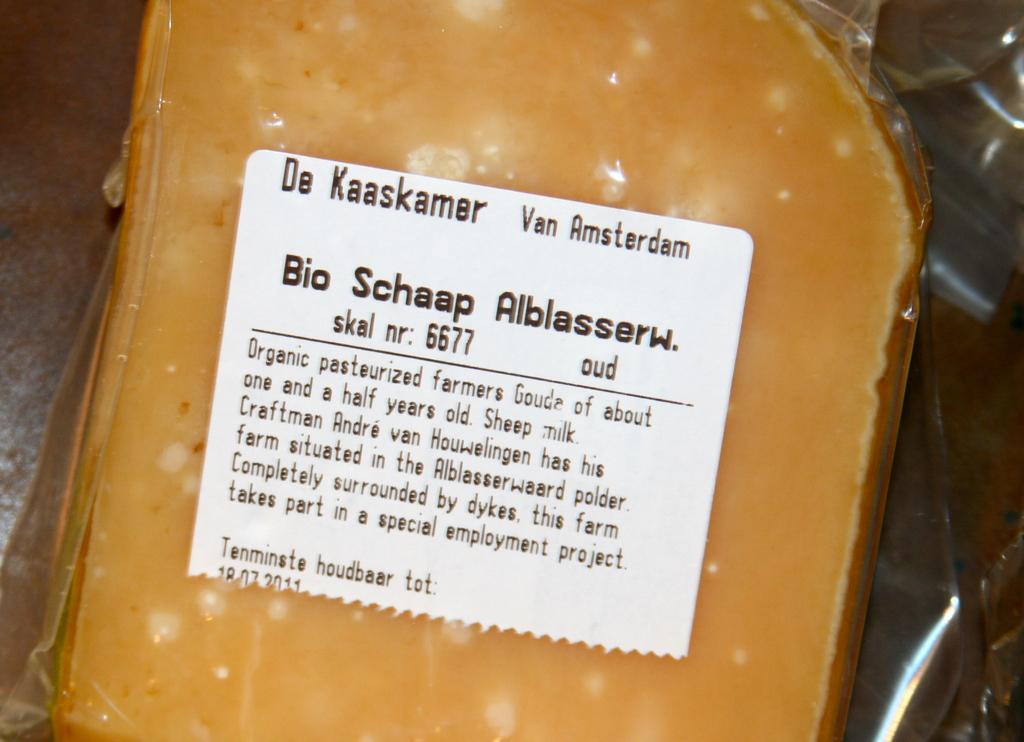Please provide a concise description of this image. The picture I can see an yellow color object is placed in the transparent cover and here I can see a white color sticker on which I can see some text. 